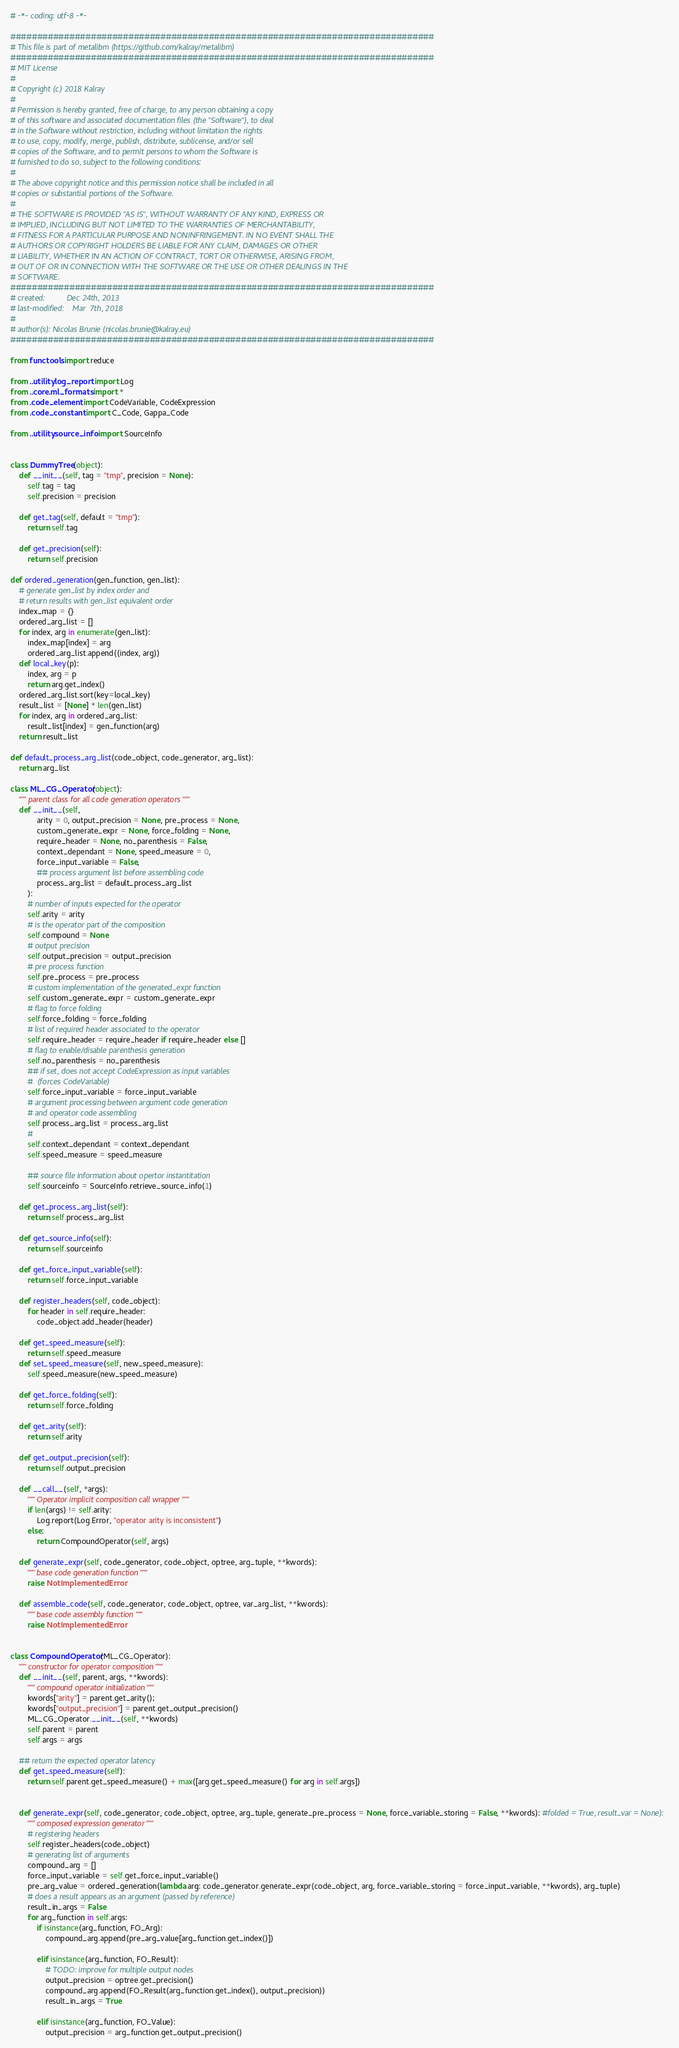Convert code to text. <code><loc_0><loc_0><loc_500><loc_500><_Python_># -*- coding: utf-8 -*-

###############################################################################
# This file is part of metalibm (https://github.com/kalray/metalibm)
###############################################################################
# MIT License
#
# Copyright (c) 2018 Kalray
#
# Permission is hereby granted, free of charge, to any person obtaining a copy
# of this software and associated documentation files (the "Software"), to deal
# in the Software without restriction, including without limitation the rights
# to use, copy, modify, merge, publish, distribute, sublicense, and/or sell
# copies of the Software, and to permit persons to whom the Software is
# furnished to do so, subject to the following conditions:
#
# The above copyright notice and this permission notice shall be included in all
# copies or substantial portions of the Software.
#
# THE SOFTWARE IS PROVIDED "AS IS", WITHOUT WARRANTY OF ANY KIND, EXPRESS OR
# IMPLIED, INCLUDING BUT NOT LIMITED TO THE WARRANTIES OF MERCHANTABILITY,
# FITNESS FOR A PARTICULAR PURPOSE AND NONINFRINGEMENT. IN NO EVENT SHALL THE
# AUTHORS OR COPYRIGHT HOLDERS BE LIABLE FOR ANY CLAIM, DAMAGES OR OTHER
# LIABILITY, WHETHER IN AN ACTION OF CONTRACT, TORT OR OTHERWISE, ARISING FROM,
# OUT OF OR IN CONNECTION WITH THE SOFTWARE OR THE USE OR OTHER DEALINGS IN THE
# SOFTWARE.
###############################################################################
# created:          Dec 24th, 2013
# last-modified:    Mar  7th, 2018
#
# author(s): Nicolas Brunie (nicolas.brunie@kalray.eu)
###############################################################################

from functools import reduce

from ..utility.log_report import Log
from ..core.ml_formats import *
from .code_element import CodeVariable, CodeExpression
from .code_constant import C_Code, Gappa_Code

from ..utility.source_info import SourceInfo


class DummyTree(object):
    def __init__(self, tag = "tmp", precision = None):
        self.tag = tag
        self.precision = precision

    def get_tag(self, default = "tmp"):
        return self.tag

    def get_precision(self):
        return self.precision

def ordered_generation(gen_function, gen_list):
    # generate gen_list by index order and
    # return results with gen_list equivalent order
    index_map = {}
    ordered_arg_list = []
    for index, arg in enumerate(gen_list):
        index_map[index] = arg
        ordered_arg_list.append((index, arg))
    def local_key(p):
        index, arg = p
        return arg.get_index()
    ordered_arg_list.sort(key=local_key)
    result_list = [None] * len(gen_list)
    for index, arg in ordered_arg_list:
        result_list[index] = gen_function(arg)
    return result_list

def default_process_arg_list(code_object, code_generator, arg_list):
    return arg_list

class ML_CG_Operator(object):
    """ parent class for all code generation operators """
    def __init__(self,
            arity = 0, output_precision = None, pre_process = None,
            custom_generate_expr = None, force_folding = None,
            require_header = None, no_parenthesis = False,
            context_dependant = None, speed_measure = 0,
            force_input_variable = False,
            ## process argument list before assembling code
            process_arg_list = default_process_arg_list
        ):
        # number of inputs expected for the operator
        self.arity = arity
        # is the operator part of the composition
        self.compound = None
        # output precision
        self.output_precision = output_precision
        # pre process function 
        self.pre_process = pre_process
        # custom implementation of the generated_expr function
        self.custom_generate_expr = custom_generate_expr
        # flag to force folding
        self.force_folding = force_folding
        # list of required header associated to the operator
        self.require_header = require_header if require_header else []
        # flag to enable/disable parenthesis generation
        self.no_parenthesis = no_parenthesis
        ## if set, does not accept CodeExpression as input variables
        #  (forces CodeVariable)
        self.force_input_variable = force_input_variable
        # argument processing between argument code generation
        # and operator code assembling
        self.process_arg_list = process_arg_list
        # 
        self.context_dependant = context_dependant
        self.speed_measure = speed_measure

        ## source file information about opertor instantitation
        self.sourceinfo = SourceInfo.retrieve_source_info(1)

    def get_process_arg_list(self):
        return self.process_arg_list

    def get_source_info(self):
        return self.sourceinfo

    def get_force_input_variable(self):
        return self.force_input_variable

    def register_headers(self, code_object):
        for header in self.require_header: 
            code_object.add_header(header)

    def get_speed_measure(self):
        return self.speed_measure
    def set_speed_measure(self, new_speed_measure):
        self.speed_measure(new_speed_measure)

    def get_force_folding(self):
        return self.force_folding

    def get_arity(self):
        return self.arity

    def get_output_precision(self):
        return self.output_precision

    def __call__(self, *args):
        """ Operator implicit composition call wrapper """
        if len(args) != self.arity:
            Log.report(Log.Error, "operator arity is inconsistent")
        else:
            return CompoundOperator(self, args) 

    def generate_expr(self, code_generator, code_object, optree, arg_tuple, **kwords):
        """ base code generation function """
        raise NotImplementedError 

    def assemble_code(self, code_generator, code_object, optree, var_arg_list, **kwords):
        """ base code assembly function """
        raise NotImplementedError


class CompoundOperator(ML_CG_Operator):
    """ constructor for operator composition """
    def __init__(self, parent, args, **kwords):
        """ compound operator initialization """
        kwords["arity"] = parent.get_arity();
        kwords["output_precision"] = parent.get_output_precision()
        ML_CG_Operator.__init__(self, **kwords)
        self.parent = parent
        self.args = args

    ## return the expected operator latency
    def get_speed_measure(self):
        return self.parent.get_speed_measure() + max([arg.get_speed_measure() for arg in self.args])


    def generate_expr(self, code_generator, code_object, optree, arg_tuple, generate_pre_process = None, force_variable_storing = False, **kwords): #folded = True, result_var = None):
        """ composed expression generator """
        # registering headers
        self.register_headers(code_object)
        # generating list of arguments
        compound_arg = []
        force_input_variable = self.get_force_input_variable()
        pre_arg_value = ordered_generation(lambda arg: code_generator.generate_expr(code_object, arg, force_variable_storing = force_input_variable, **kwords), arg_tuple)
        # does a result appears as an argument (passed by reference)
        result_in_args = False
        for arg_function in self.args:
            if isinstance(arg_function, FO_Arg):
                compound_arg.append(pre_arg_value[arg_function.get_index()])

            elif isinstance(arg_function, FO_Result):
                # TODO: improve for multiple output nodes
                output_precision = optree.get_precision()
                compound_arg.append(FO_Result(arg_function.get_index(), output_precision))
                result_in_args = True

            elif isinstance(arg_function, FO_Value):
                output_precision = arg_function.get_output_precision()</code> 